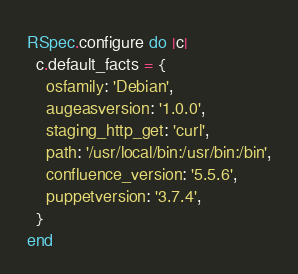<code> <loc_0><loc_0><loc_500><loc_500><_Ruby_>RSpec.configure do |c|
  c.default_facts = {
    osfamily: 'Debian',
    augeasversion: '1.0.0',
    staging_http_get: 'curl',
    path: '/usr/local/bin:/usr/bin:/bin',
    confluence_version: '5.5.6',
    puppetversion: '3.7.4',
  }
end
</code> 